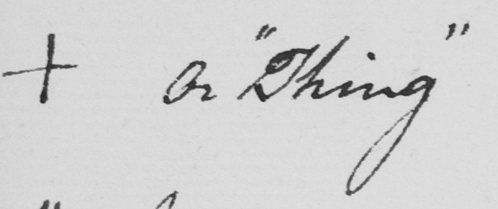What does this handwritten line say? +  Or  " Thing " 